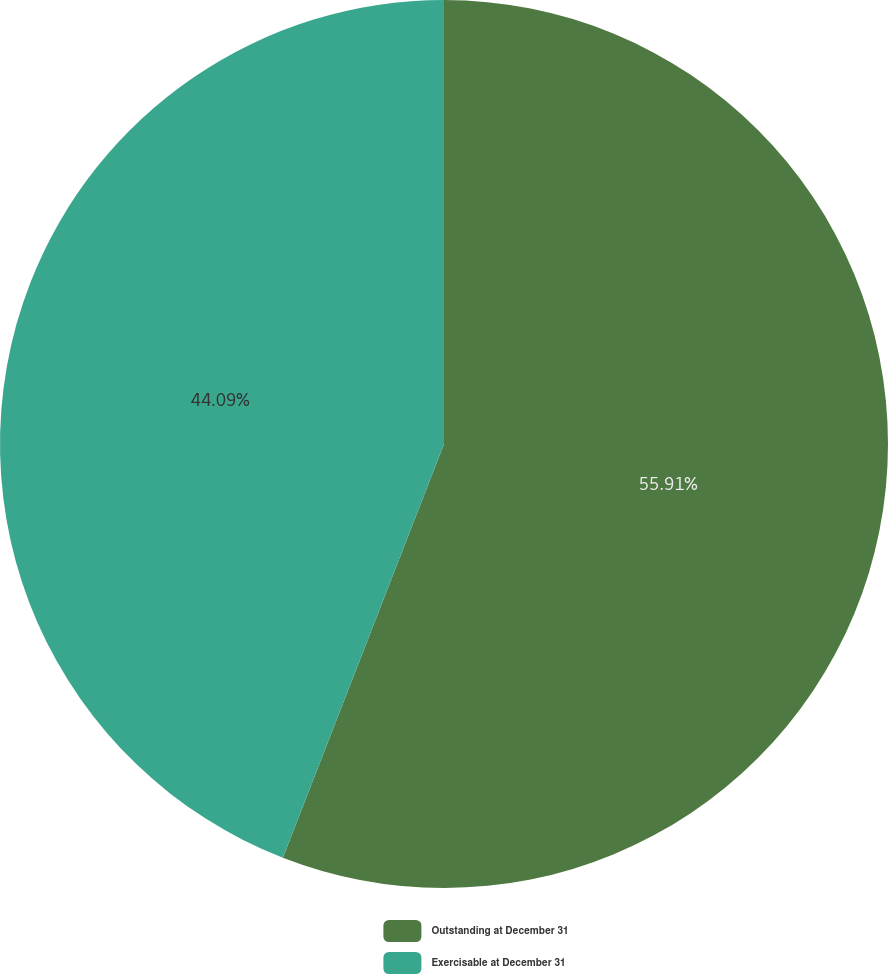Convert chart. <chart><loc_0><loc_0><loc_500><loc_500><pie_chart><fcel>Outstanding at December 31<fcel>Exercisable at December 31<nl><fcel>55.91%<fcel>44.09%<nl></chart> 